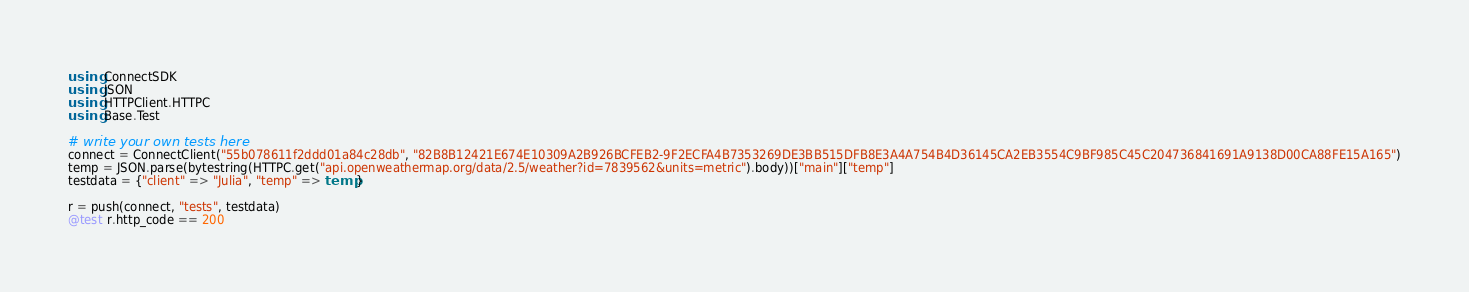Convert code to text. <code><loc_0><loc_0><loc_500><loc_500><_Julia_>using ConnectSDK
using JSON
using HTTPClient.HTTPC
using Base.Test

# write your own tests here
connect = ConnectClient("55b078611f2ddd01a84c28db", "82B8B12421E674E10309A2B926BCFEB2-9F2ECFA4B7353269DE3BB515DFB8E3A4A754B4D36145CA2EB3554C9BF985C45C204736841691A9138D00CA88FE15A165")
temp = JSON.parse(bytestring(HTTPC.get("api.openweathermap.org/data/2.5/weather?id=7839562&units=metric").body))["main"]["temp"]
testdata = {"client" => "Julia", "temp" => temp}

r = push(connect, "tests", testdata)
@test r.http_code == 200
</code> 